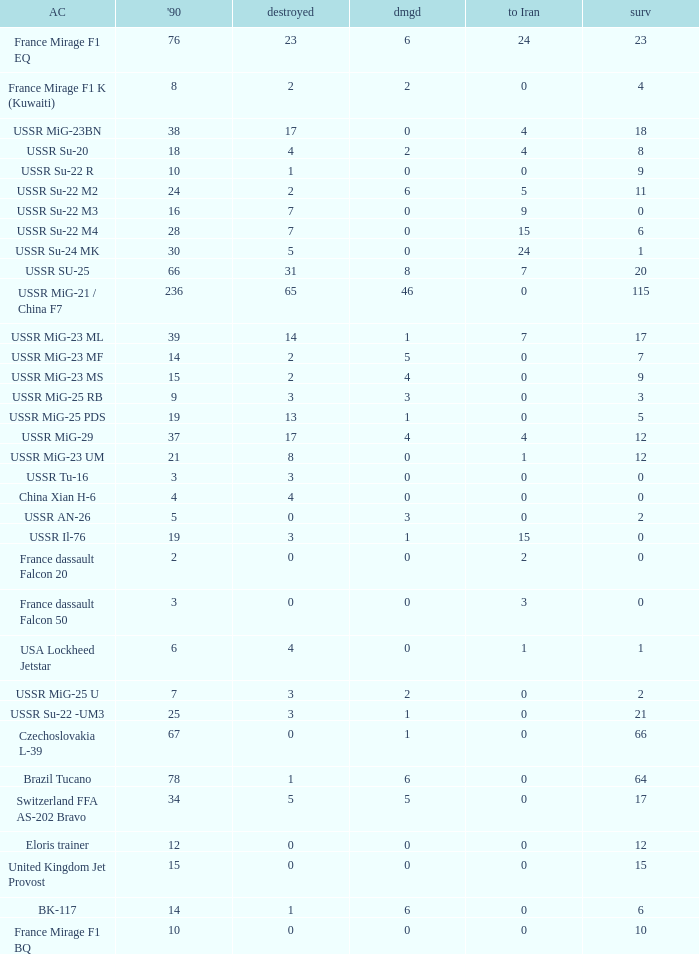If there were 14 in 1990 and 6 survived how many were destroyed? 1.0. 